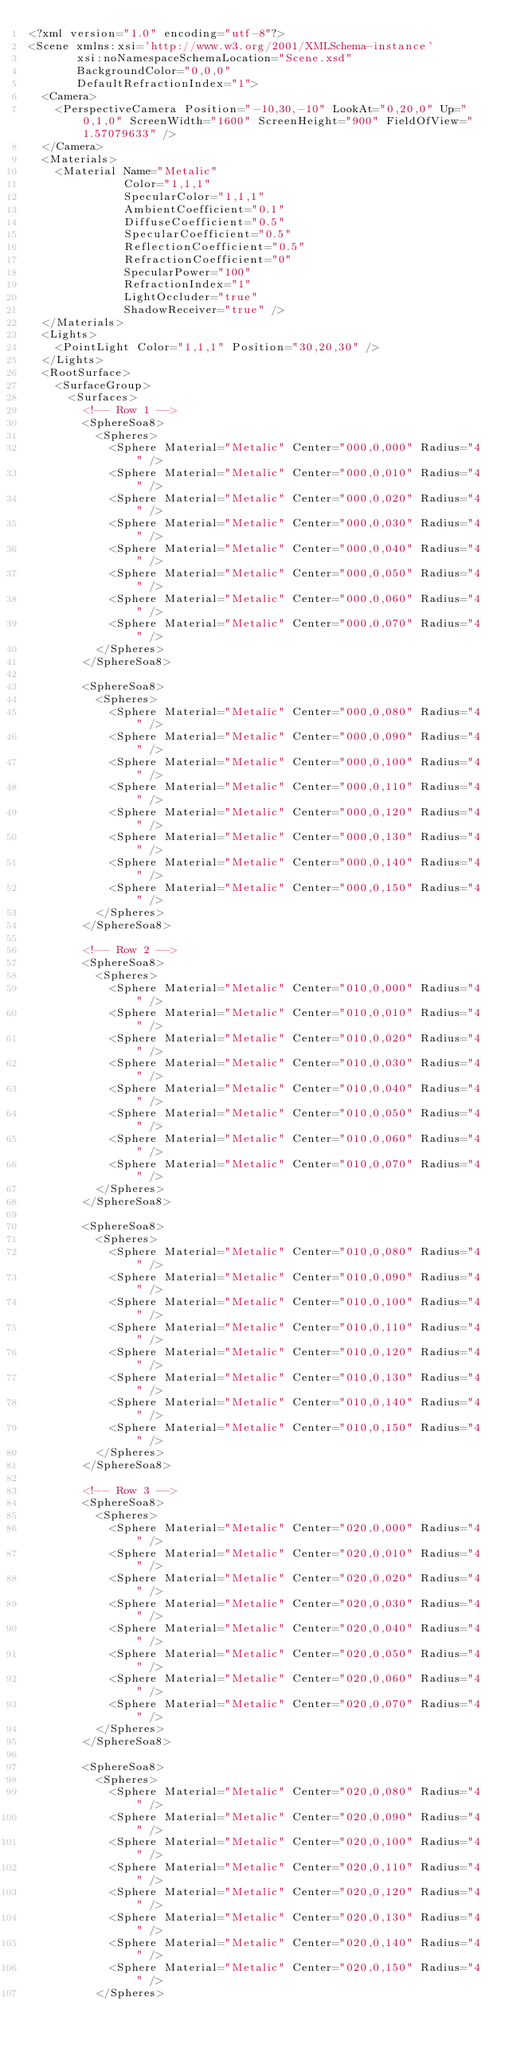<code> <loc_0><loc_0><loc_500><loc_500><_XML_><?xml version="1.0" encoding="utf-8"?>
<Scene xmlns:xsi='http://www.w3.org/2001/XMLSchema-instance'
       xsi:noNamespaceSchemaLocation="Scene.xsd"
       BackgroundColor="0,0,0"
       DefaultRefractionIndex="1">
  <Camera>
    <PerspectiveCamera Position="-10,30,-10" LookAt="0,20,0" Up="0,1,0" ScreenWidth="1600" ScreenHeight="900" FieldOfView="1.57079633" />
  </Camera>
  <Materials>
    <Material Name="Metalic"
              Color="1,1,1"
              SpecularColor="1,1,1"
              AmbientCoefficient="0.1"
              DiffuseCoefficient="0.5"
              SpecularCoefficient="0.5"
              ReflectionCoefficient="0.5"
              RefractionCoefficient="0"
              SpecularPower="100"
              RefractionIndex="1"
              LightOccluder="true"
              ShadowReceiver="true" />
  </Materials>
  <Lights>
    <PointLight Color="1,1,1" Position="30,20,30" />
  </Lights>
  <RootSurface>
    <SurfaceGroup>
      <Surfaces>
        <!-- Row 1 -->
        <SphereSoa8>
          <Spheres>
            <Sphere Material="Metalic" Center="000,0,000" Radius="4" />
            <Sphere Material="Metalic" Center="000,0,010" Radius="4" />
            <Sphere Material="Metalic" Center="000,0,020" Radius="4" />
            <Sphere Material="Metalic" Center="000,0,030" Radius="4" />
            <Sphere Material="Metalic" Center="000,0,040" Radius="4" />
            <Sphere Material="Metalic" Center="000,0,050" Radius="4" />
            <Sphere Material="Metalic" Center="000,0,060" Radius="4" />
            <Sphere Material="Metalic" Center="000,0,070" Radius="4" />
          </Spheres>
        </SphereSoa8>

        <SphereSoa8>
          <Spheres>
            <Sphere Material="Metalic" Center="000,0,080" Radius="4" />
            <Sphere Material="Metalic" Center="000,0,090" Radius="4" />
            <Sphere Material="Metalic" Center="000,0,100" Radius="4" />
            <Sphere Material="Metalic" Center="000,0,110" Radius="4" />
            <Sphere Material="Metalic" Center="000,0,120" Radius="4" />
            <Sphere Material="Metalic" Center="000,0,130" Radius="4" />
            <Sphere Material="Metalic" Center="000,0,140" Radius="4" />
            <Sphere Material="Metalic" Center="000,0,150" Radius="4" />
          </Spheres>
        </SphereSoa8>

        <!-- Row 2 -->
        <SphereSoa8>
          <Spheres>
            <Sphere Material="Metalic" Center="010,0,000" Radius="4" />
            <Sphere Material="Metalic" Center="010,0,010" Radius="4" />
            <Sphere Material="Metalic" Center="010,0,020" Radius="4" />
            <Sphere Material="Metalic" Center="010,0,030" Radius="4" />
            <Sphere Material="Metalic" Center="010,0,040" Radius="4" />
            <Sphere Material="Metalic" Center="010,0,050" Radius="4" />
            <Sphere Material="Metalic" Center="010,0,060" Radius="4" />
            <Sphere Material="Metalic" Center="010,0,070" Radius="4" />
          </Spheres>
        </SphereSoa8>

        <SphereSoa8>
          <Spheres>
            <Sphere Material="Metalic" Center="010,0,080" Radius="4" />
            <Sphere Material="Metalic" Center="010,0,090" Radius="4" />
            <Sphere Material="Metalic" Center="010,0,100" Radius="4" />
            <Sphere Material="Metalic" Center="010,0,110" Radius="4" />
            <Sphere Material="Metalic" Center="010,0,120" Radius="4" />
            <Sphere Material="Metalic" Center="010,0,130" Radius="4" />
            <Sphere Material="Metalic" Center="010,0,140" Radius="4" />
            <Sphere Material="Metalic" Center="010,0,150" Radius="4" />
          </Spheres>
        </SphereSoa8>

        <!-- Row 3 -->
        <SphereSoa8>
          <Spheres>
            <Sphere Material="Metalic" Center="020,0,000" Radius="4" />
            <Sphere Material="Metalic" Center="020,0,010" Radius="4" />
            <Sphere Material="Metalic" Center="020,0,020" Radius="4" />
            <Sphere Material="Metalic" Center="020,0,030" Radius="4" />
            <Sphere Material="Metalic" Center="020,0,040" Radius="4" />
            <Sphere Material="Metalic" Center="020,0,050" Radius="4" />
            <Sphere Material="Metalic" Center="020,0,060" Radius="4" />
            <Sphere Material="Metalic" Center="020,0,070" Radius="4" />
          </Spheres>
        </SphereSoa8>

        <SphereSoa8>
          <Spheres>
            <Sphere Material="Metalic" Center="020,0,080" Radius="4" />
            <Sphere Material="Metalic" Center="020,0,090" Radius="4" />
            <Sphere Material="Metalic" Center="020,0,100" Radius="4" />
            <Sphere Material="Metalic" Center="020,0,110" Radius="4" />
            <Sphere Material="Metalic" Center="020,0,120" Radius="4" />
            <Sphere Material="Metalic" Center="020,0,130" Radius="4" />
            <Sphere Material="Metalic" Center="020,0,140" Radius="4" />
            <Sphere Material="Metalic" Center="020,0,150" Radius="4" />
          </Spheres></code> 